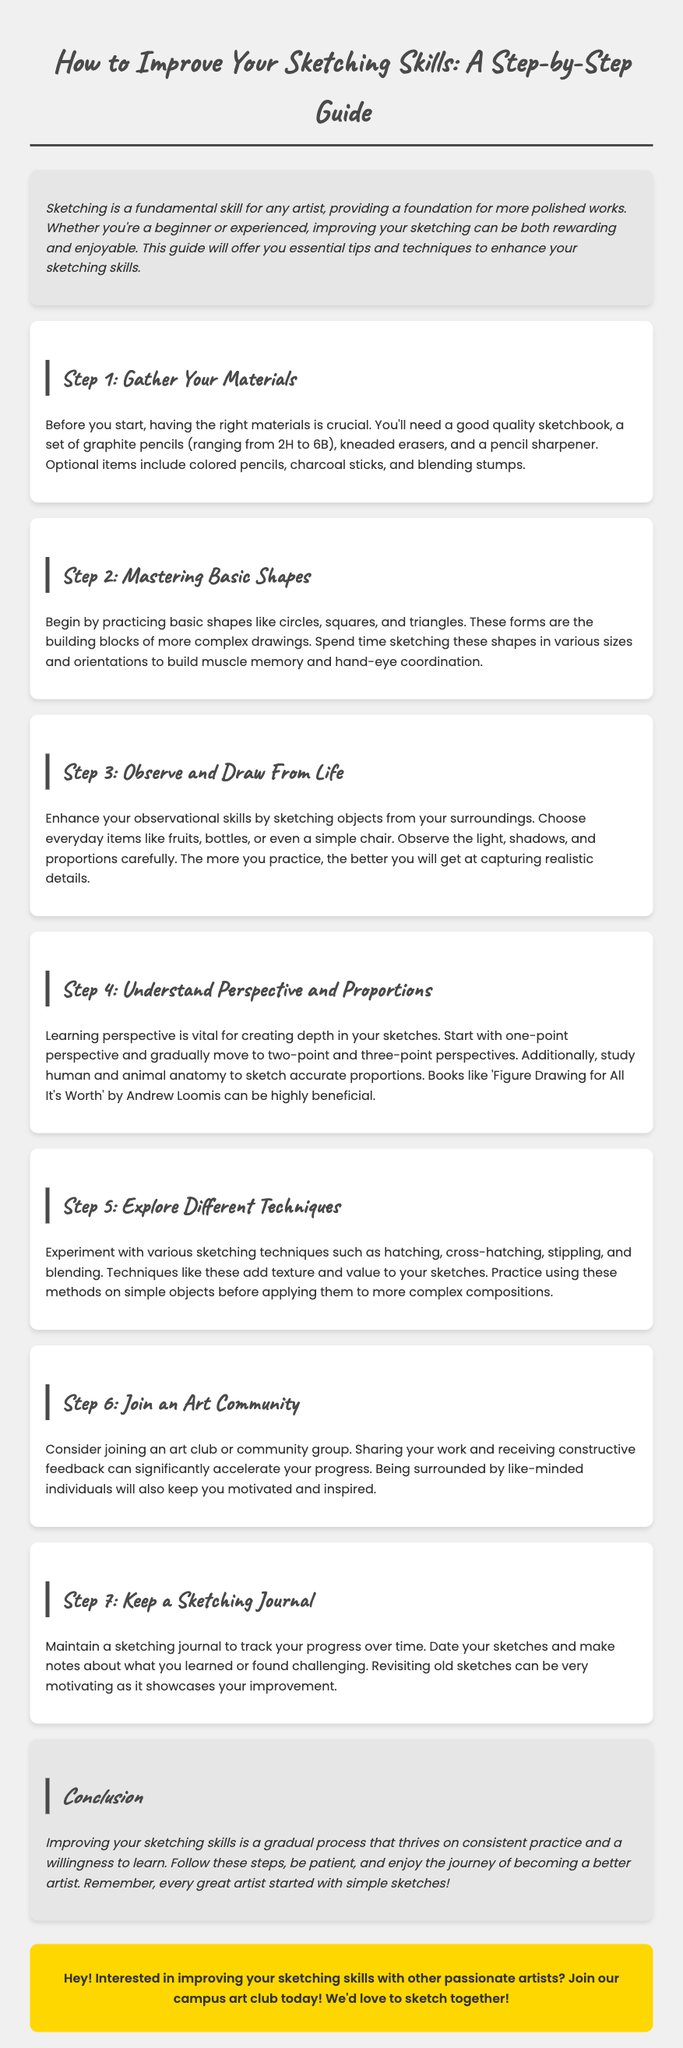What is the title of the guide? The title introduces the main topic of the document about improving sketching skills.
Answer: How to Improve Your Sketching Skills: A Student's Guide What materials are recommended to gather? This information includes the essential items needed before starting to sketch.
Answer: Sketchbook, graphite pencils, kneaded erasers, pencil sharpener What is the first step in the guide? The first step outlines the importance of preparing the right materials for sketching.
Answer: Gather Your Materials How many types of perspective are mentioned? The guide mentions the progression of skills in drawing perspectives.
Answer: Three What should you observe while drawing from life? The document emphasizes key observational aspects to focus on during the drawing process.
Answer: Light, shadows, and proportions Which book is recommended for studying anatomy? This question refers to a specific resource mentioned for better understanding of human and animal proportions.
Answer: Figure Drawing for All It's Worth What technique is suggested to add texture to sketches? The guide highlights various techniques used in sketching for effect and detail.
Answer: Hatching, cross-hatching, stippling, and blending What is the purpose of keeping a sketching journal? The guide describes the benefits of tracking progression and learning through a sketchbook.
Answer: To track progress over time What can joining an art community provide? This question addresses the advantages of collaborative learning mentioned in the guide.
Answer: Constructive feedback and motivation 